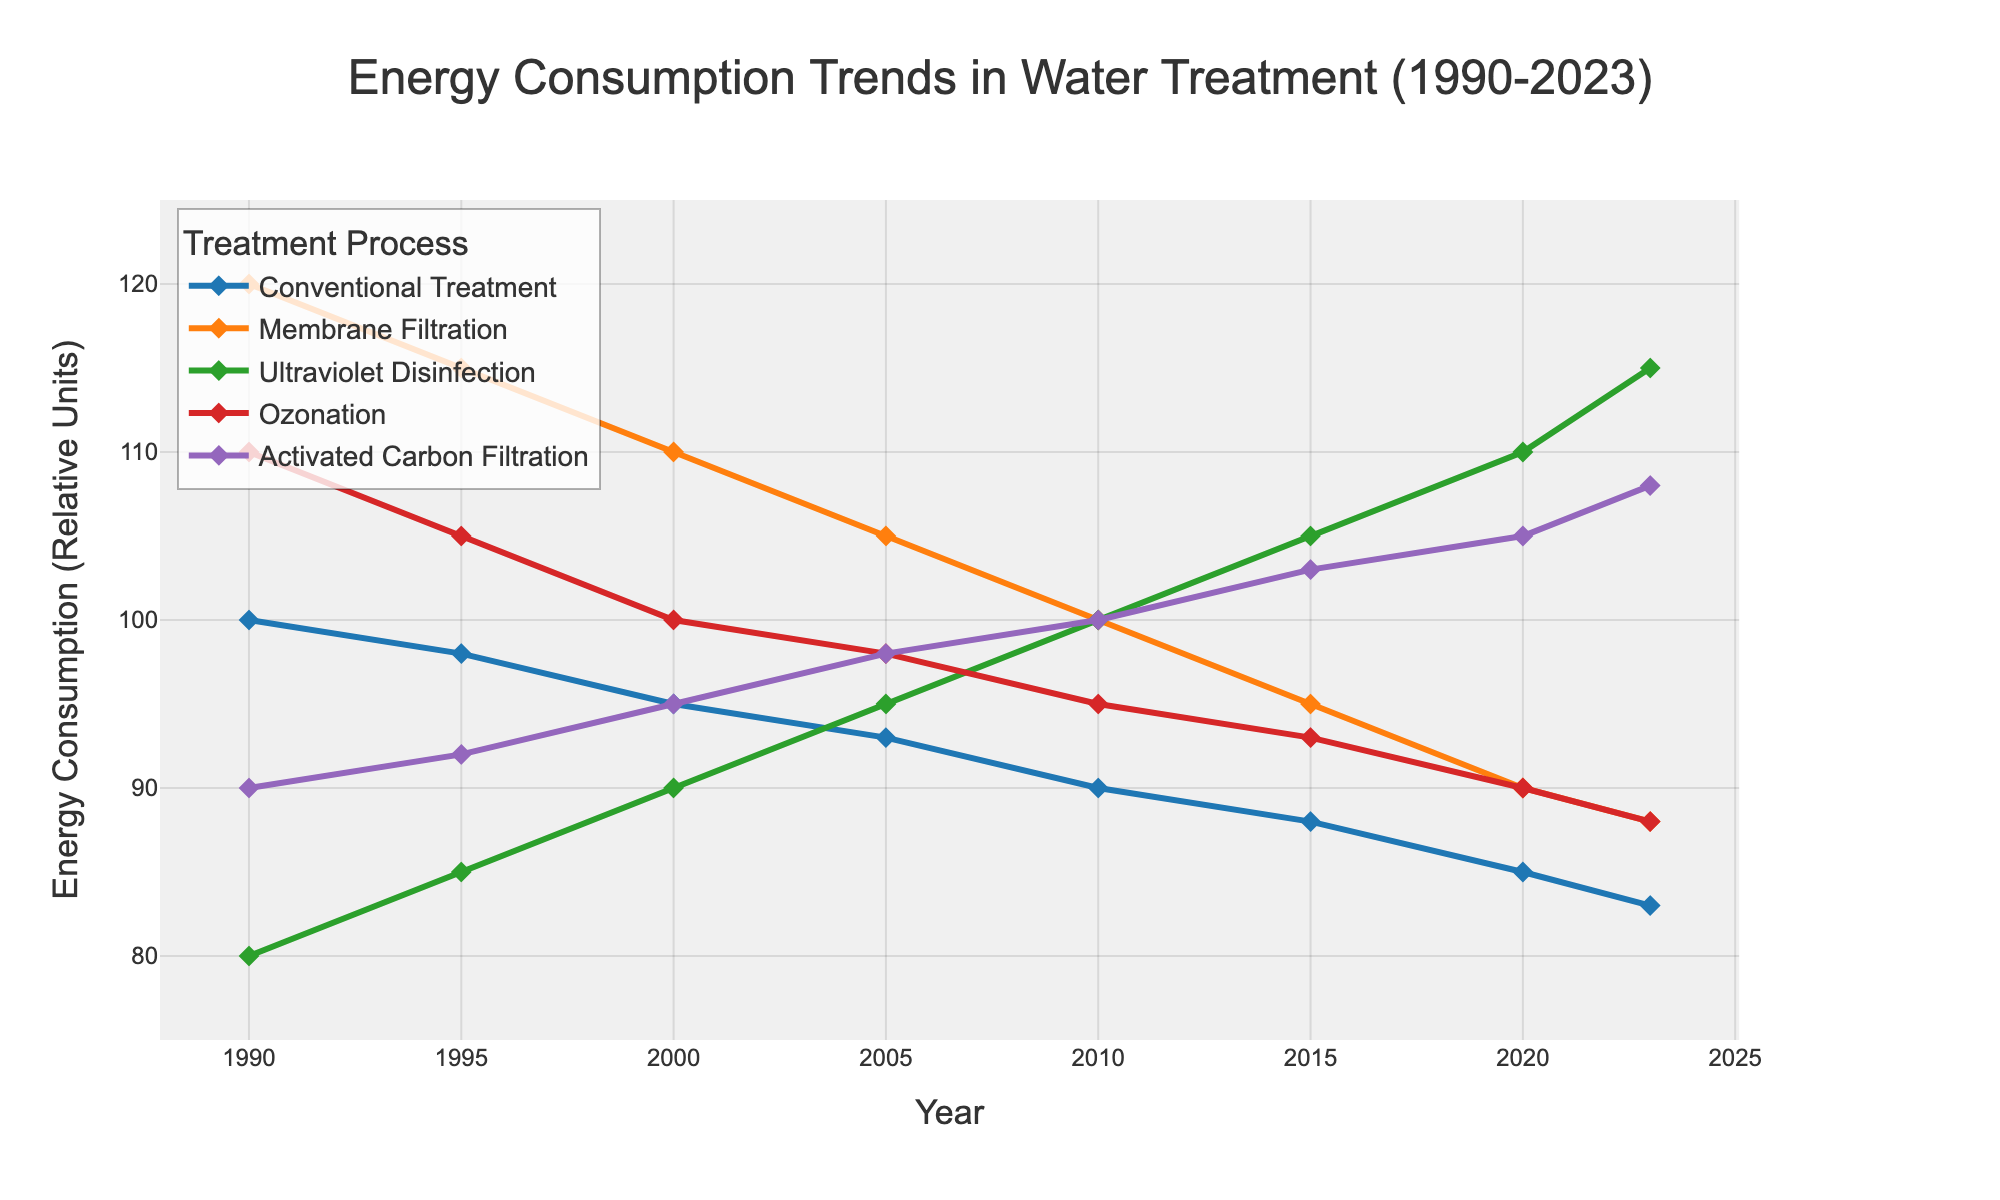How has the energy consumption of Membrane Filtration changed from 1990 to 2023? In 1990, Membrane Filtration started at a value of 120. By 2023, the consumption dropped to 88. Hence, the change is 120 - 88 = 32 units of decrease over the period.
Answer: Decreased by 32 units Which treatment process had the highest energy consumption in 2005? The values for 2005 are: Conventional Treatment (93), Membrane Filtration (105), Ultraviolet Disinfection (95), Ozonation (98), and Activated Carbon Filtration (98). Membrane Filtration has the highest consumption of 105 units.
Answer: Membrane Filtration In which year did Ultraviolet Disinfection overtake Conventional Treatment in energy consumption? By analyzing the plot, Ultraviolet Disinfection overtook Conventional Treatment in energy consumption for the first time in 2005 when the values became 95 (Ultraviolet Disinfection) vs 93 (Conventional Treatment).
Answer: 2005 Between 2010 and 2023, which treatment process showed the most consistent decrease in energy consumption? Observing the trend lines, both Conventional Treatment and Ozonation showed a steady decrease. However, Conventional Treatment decreased steadily from 90 in 2010 to 83 in 2023, while Ozonation dropped from 95 to 88 in a more absolute manner.
Answer: Conventional Treatment What is the average energy consumption of Activated Carbon Filtration from 2010 to 2023? The values for Activated Carbon Filtration from 2010 to 2023 are 100, 103, 105, and 108. The average is calculated as (100 + 103 + 105 + 108) / 4 = 416 / 4 = 104.
Answer: 104 units Which two treatment processes had intersecting energy consumption values, and in which year did that occur after 2000? From the plot, we can observe Activated Carbon Filtration and Ultraviolet Disinfection intersected in 2015 with values of 105.
Answer: Activated Carbon Filtration and Ultraviolet Disinfection in 2015 By how much did the energy consumption of Ultraviolet Disinfection change from 2000 to 2023? Ultraviolet Disinfection had values of 90 in 2000 and 115 in 2023. The change is 115 - 90 = 25 units increase.
Answer: Increased by 25 units Which treatment process had the smallest change in energy consumption between 1990 and 2023? By examining the changes, Activated Carbon Filtration had values of 90 in 1990 and 108 in 2023, resulting in an 18-unit increase. This is comparatively smaller to other changes.
Answer: Activated Carbon Filtration What was the total energy consumption for all processes in 2015? The values for 2015 are: Conventional Treatment (88), Membrane Filtration (95), Ultraviolet Disinfection (105), Ozonation (93), and Activated Carbon Filtration (103). Summing up: 88 + 95 + 105 + 93 + 103 = 484 units.
Answer: 484 units Which treatment processes showed a decreasing trend in energy consumption from 1990 to 2023? The processes with clearly decreasing trends are Conventional Treatment and Ozonation.
Answer: Conventional Treatment and Ozonation 